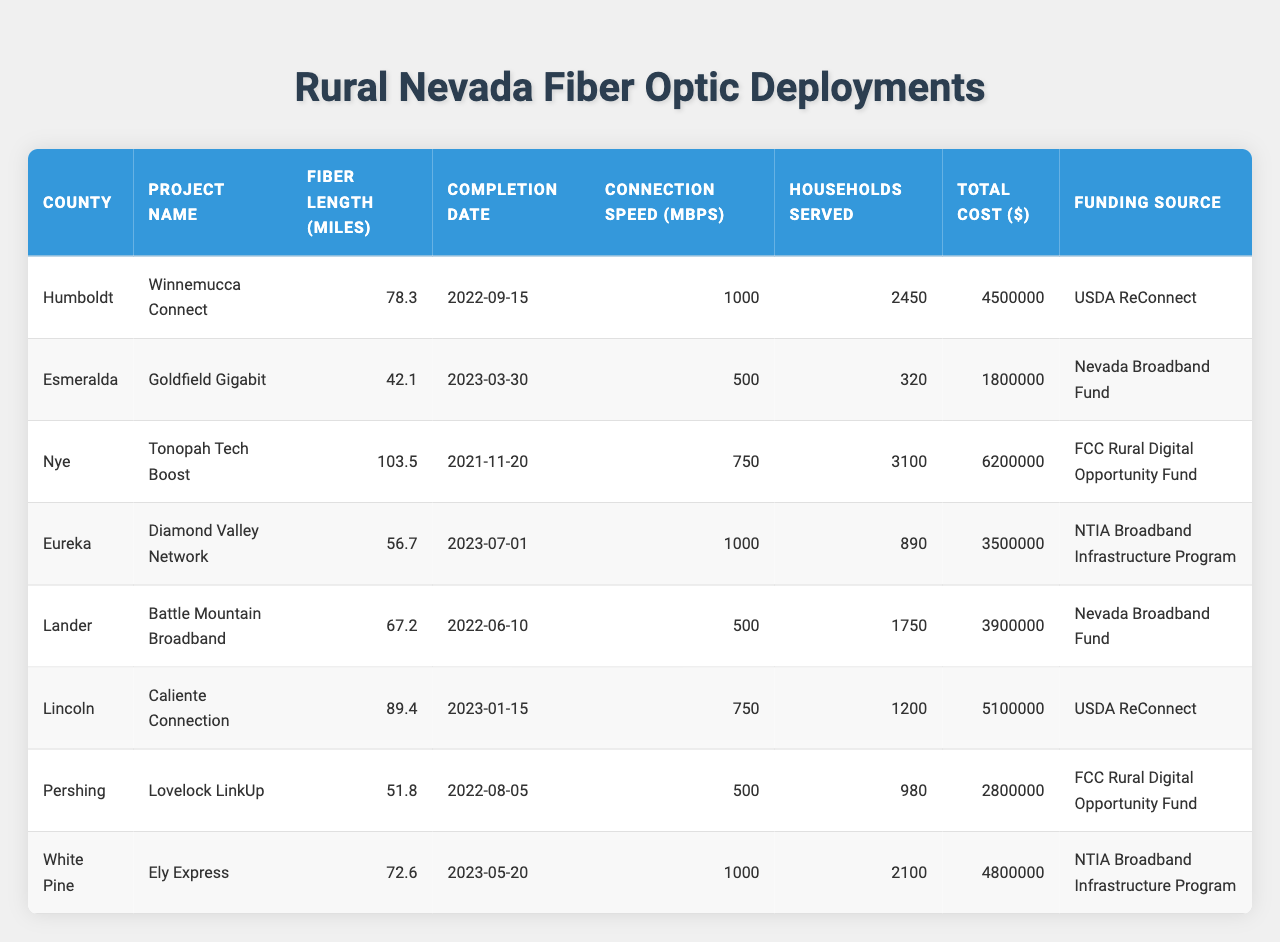What's the total fiber length deployed across all listed counties? To find the total fiber length, add the fiber lengths from each county: 78.3 + 42.1 + 103.5 + 56.7 + 67.2 + 89.4 + 51.8 + 72.6 = 461.6 miles.
Answer: 461.6 miles Which project serves the highest number of households? Looking at the "Households Served" column, the Tonopah Tech Boost project serves 3100 households, which is the highest among all entries.
Answer: Tonopah Tech Boost What is the average connection speed for the projects listed? The connection speeds are: 1000, 500, 750, 1000, 500, 750, 500, 1000. The sum is 1000 + 500 + 750 + 1000 + 500 + 750 + 500 + 1000 = 5050. There are 8 projects, so the average speed is 5050/8 = 631.25 Mbps.
Answer: 631.25 Mbps Is there a project with a completion date in 2023? Yes, upon reviewing the "Completion Date" column, the projects Goldfield Gigabit, Diamond Valley Network, Caliente Connection, Ely Express have completion dates in 2023.
Answer: Yes What county had the highest total cost for fiber deployment? The total costs according to the "Total Cost" column are: 4500000, 1800000, 6200000, 3500000, 3900000, 5100000, 2800000, 4800000. The highest value is 6200000 for Nye County.
Answer: Nye Which project has the lowest connection speed and how many households does it serve? The project with the lowest connection speed is Goldfield Gigabit with a speed of 500 Mbps, serving 320 households.
Answer: Goldfield Gigabit, 320 households What is the total cost of all fiber deployments funded by the USDA ReConnect? The relevant projects are Winnemucca Connect ($4,500,000) and Caliente Connection ($5,100,000). Their total cost is 4500000 + 5100000 = 9600000.
Answer: $9,600,000 How many projects have a fiber length of over 70 miles? Examining the "Fiber Length" column, the projects with lengths over 70 miles are: Winnemucca Connect (78.3), Tonopah Tech Boost (103.5), Lincoln County (89.4), and Ely Express (72.6). That gives a total of 4 projects.
Answer: 4 projects What is the funding source of the project serving the most households? The project that serves the most households is Tonopah Tech Boost, with a funding source from the FCC Rural Digital Opportunity Fund.
Answer: FCC Rural Digital Opportunity Fund How does the average cost per household compare across the projects? The costs per household can be calculated by dividing the total cost by the number of households for each project. For example, Winnemucca Connect: 4500000/2450 = 1836.73. It requires calculating for all and averaging those values to understand the comparison. The average can be derived from: (1836.73 + 5625 + 2000 + 3937.08 + 2228.57 + 4250 + 2857.14 + 2285.71) / 8 = 2634.64 approximately.
Answer: About $2634.64 